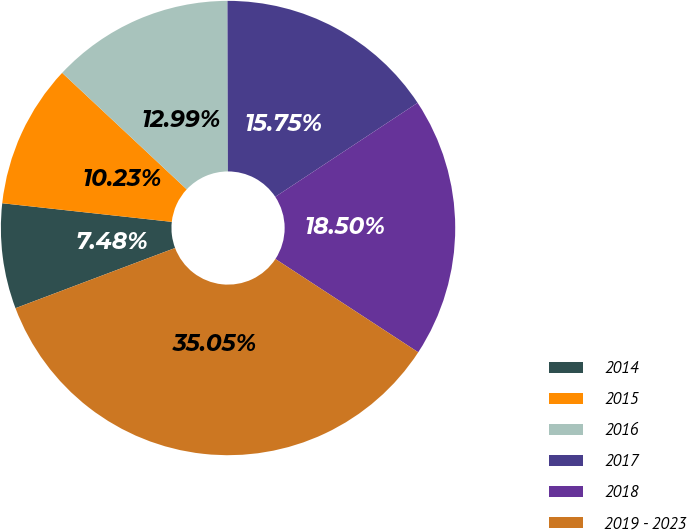Convert chart to OTSL. <chart><loc_0><loc_0><loc_500><loc_500><pie_chart><fcel>2014<fcel>2015<fcel>2016<fcel>2017<fcel>2018<fcel>2019 - 2023<nl><fcel>7.48%<fcel>10.23%<fcel>12.99%<fcel>15.75%<fcel>18.5%<fcel>35.05%<nl></chart> 